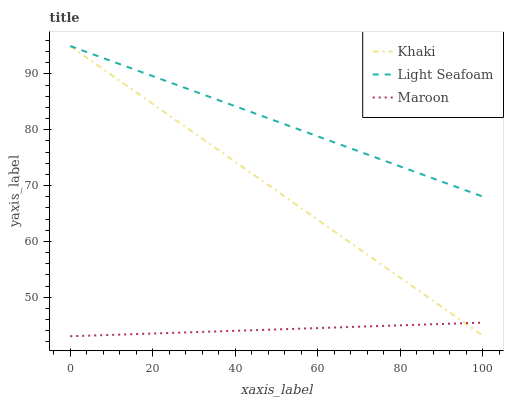Does Maroon have the minimum area under the curve?
Answer yes or no. Yes. Does Light Seafoam have the maximum area under the curve?
Answer yes or no. Yes. Does Light Seafoam have the minimum area under the curve?
Answer yes or no. No. Does Maroon have the maximum area under the curve?
Answer yes or no. No. Is Khaki the smoothest?
Answer yes or no. Yes. Is Light Seafoam the roughest?
Answer yes or no. Yes. Is Maroon the smoothest?
Answer yes or no. No. Is Maroon the roughest?
Answer yes or no. No. Does Light Seafoam have the lowest value?
Answer yes or no. No. Does Light Seafoam have the highest value?
Answer yes or no. Yes. Does Maroon have the highest value?
Answer yes or no. No. Is Maroon less than Light Seafoam?
Answer yes or no. Yes. Is Light Seafoam greater than Maroon?
Answer yes or no. Yes. Does Khaki intersect Maroon?
Answer yes or no. Yes. Is Khaki less than Maroon?
Answer yes or no. No. Is Khaki greater than Maroon?
Answer yes or no. No. Does Maroon intersect Light Seafoam?
Answer yes or no. No. 